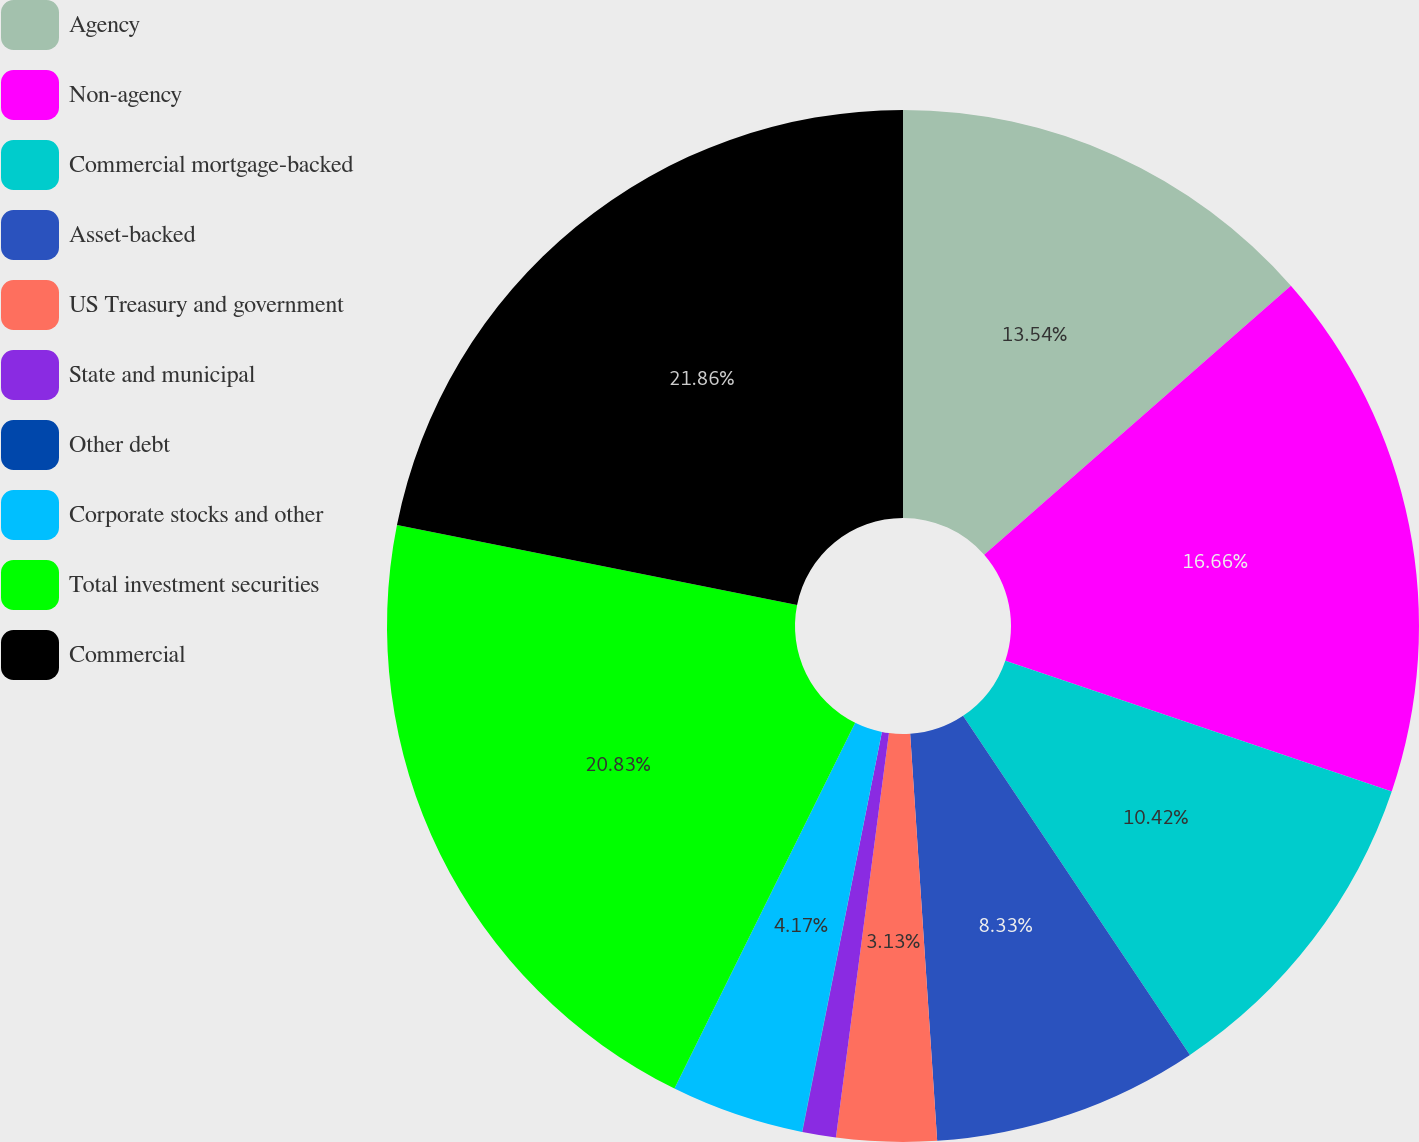<chart> <loc_0><loc_0><loc_500><loc_500><pie_chart><fcel>Agency<fcel>Non-agency<fcel>Commercial mortgage-backed<fcel>Asset-backed<fcel>US Treasury and government<fcel>State and municipal<fcel>Other debt<fcel>Corporate stocks and other<fcel>Total investment securities<fcel>Commercial<nl><fcel>13.54%<fcel>16.66%<fcel>10.42%<fcel>8.33%<fcel>3.13%<fcel>1.05%<fcel>0.01%<fcel>4.17%<fcel>20.83%<fcel>21.87%<nl></chart> 